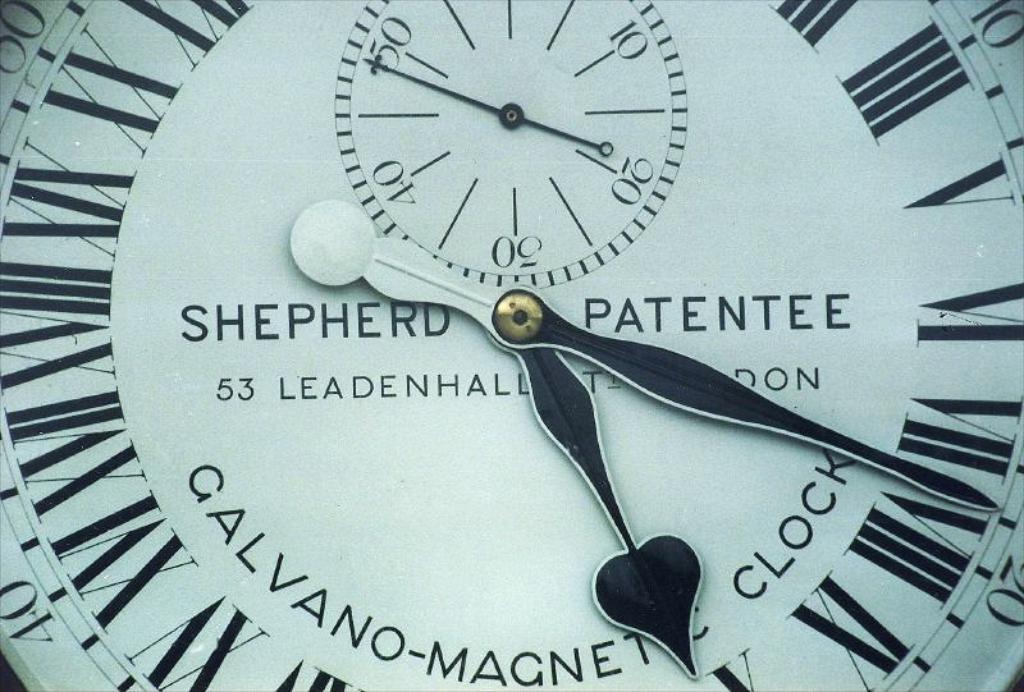Can you describe this image briefly? In the image we can see a clock, there are roman letters, numbers and these are the cock needles. 